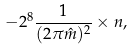Convert formula to latex. <formula><loc_0><loc_0><loc_500><loc_500>- 2 ^ { 8 } \frac { 1 } { ( 2 \pi \hat { m } ) ^ { 2 } } \times n ,</formula> 